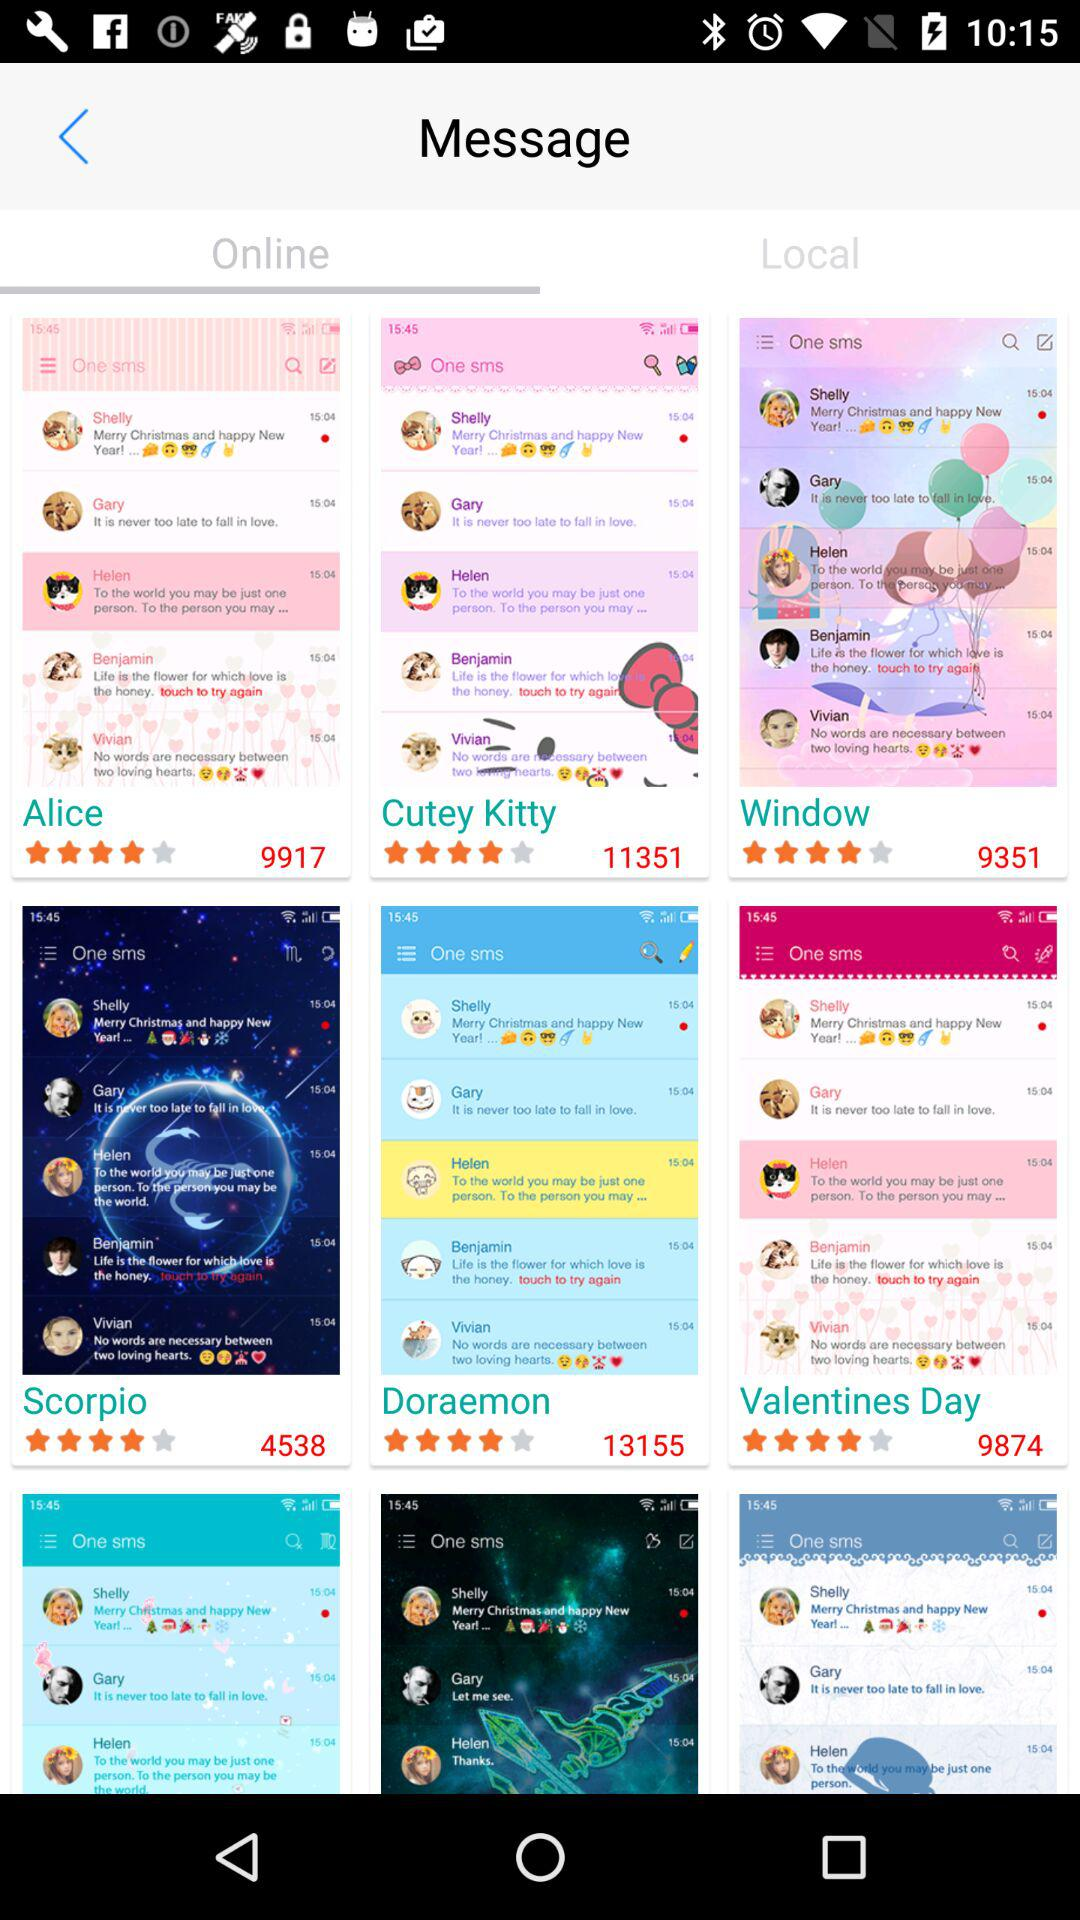Which tab has been selected? The tab that has been selected is "Online". 